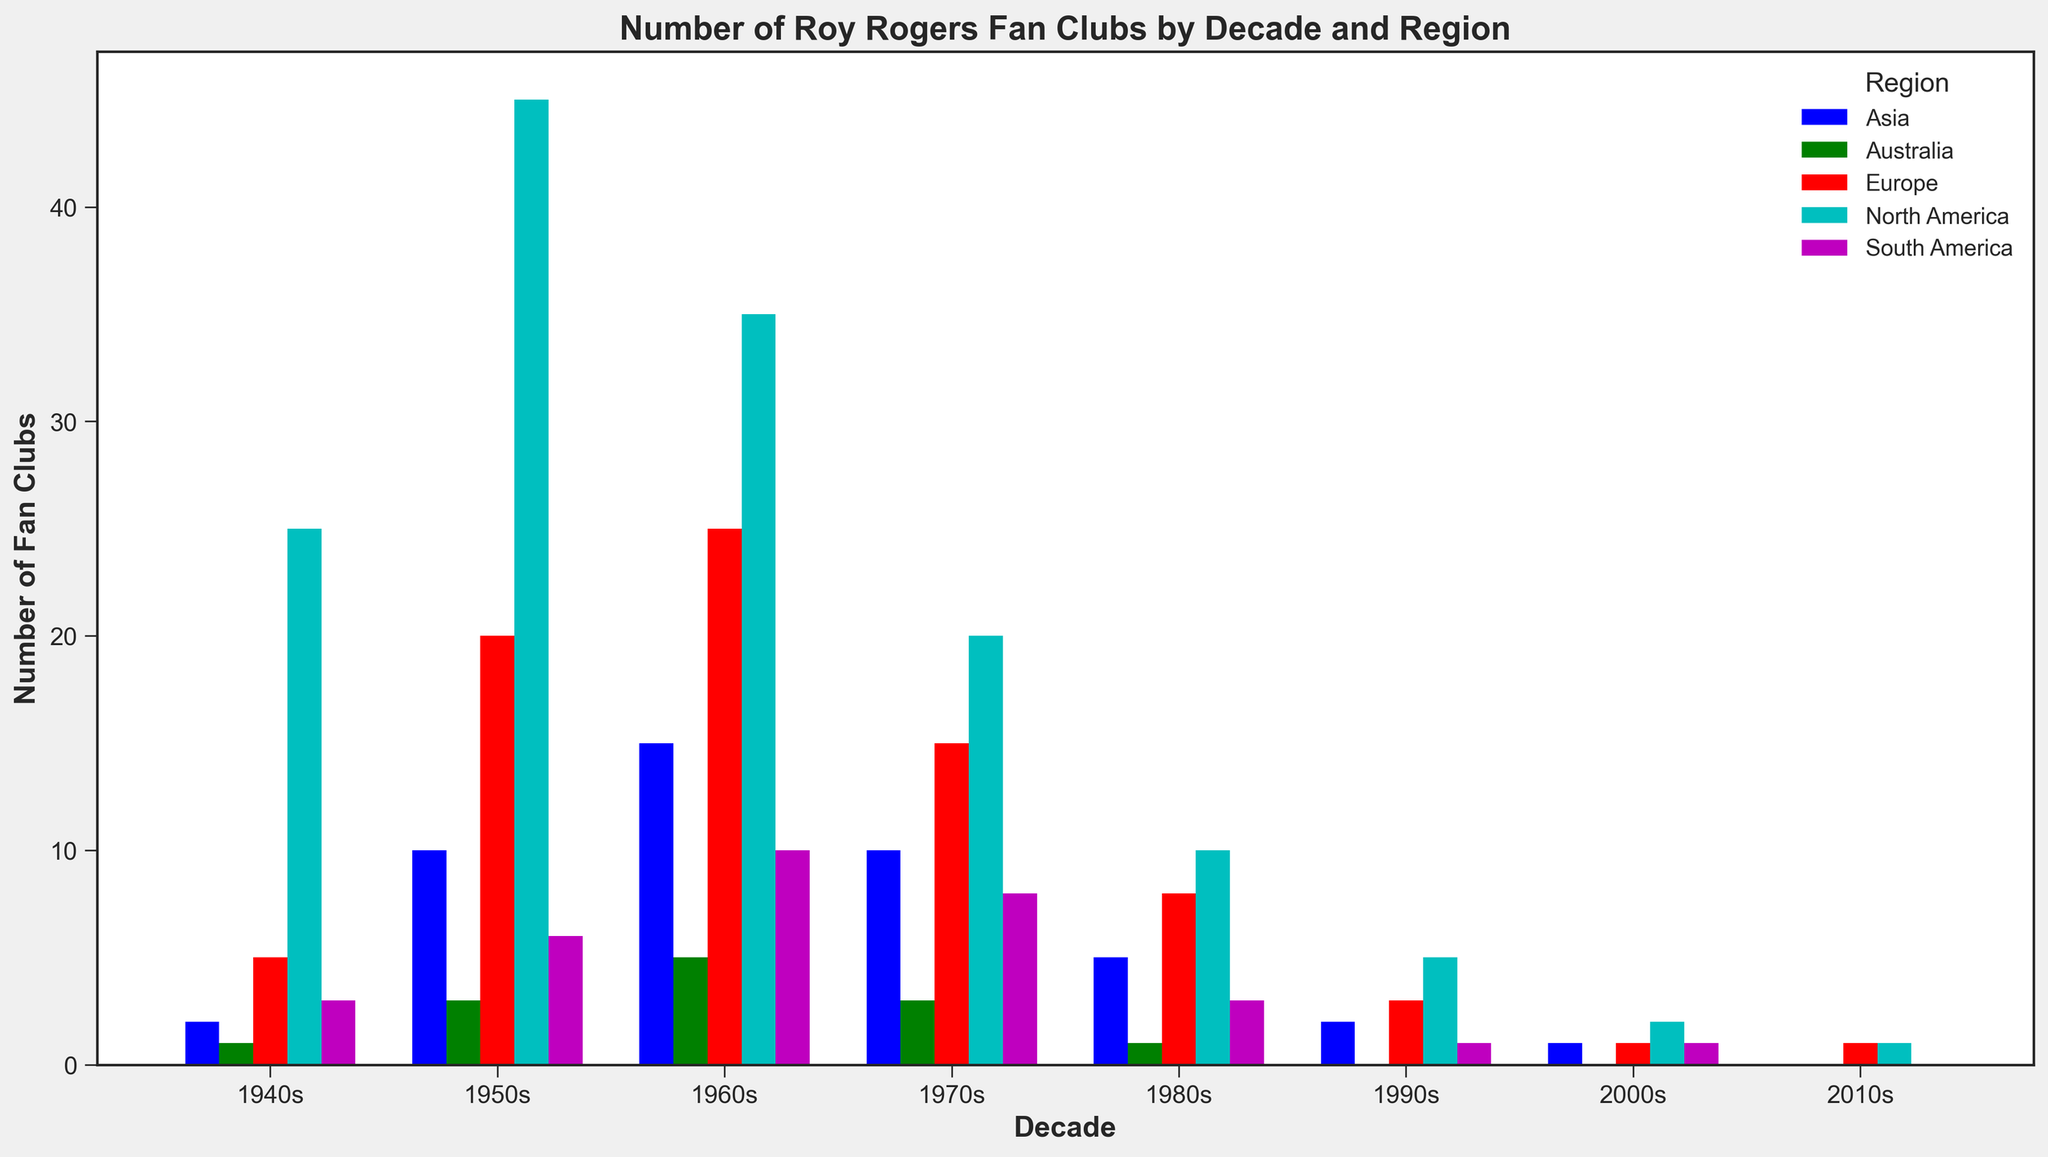Which region had the highest number of fan clubs in the 1950s? Look at the bars corresponding to the 1950s and identify the region with the tallest bar. North America's bar is the tallest in this decade.
Answer: North America How many more fan clubs were there in Europe in the 1960s compared to the 1950s? Compare the height of the bars for Europe in the 1950s and 1960s. The number for the 1960s (25) minus the number for the 1950s (20) gives us the difference.
Answer: 5 Which decade saw the highest overall number of fan clubs across all regions? Sum the heights of all bars for each decade and compare. The 1950s show the highest combined height.
Answer: 1950s How does the number of fan clubs in Asia change from the 1940s to the 2010s? Observe the height of the bars for Asia from the 1940s through to the 2010s. Asia starts with 2 in the 1940s, peaks at 15 in the 1960s, and drops to 0 in the 2010s.
Answer: Decreases What was the total number of fan clubs in the 1980s? Sum the heights of all the bars for the 1980s. (10 + 8 + 5 + 3 + 1)
Answer: 27 In which decade did South America see the largest number of fan clubs? Look at the bars representing South America and identify the decade with the tallest bar. The tallest bar is in the 1960s.
Answer: 1960s Compare the number of fan clubs in North America and Australia in the 1970s. Which had more? Compare the bars for North America and Australia in the 1970s. North America has a taller bar (20) compared to Australia (3).
Answer: North America What is the smallest number of fan clubs in any region in any decade? Identify the shortest bar across all decades and regions. The shortest bar is 0 in Australia in the 1990s and 2000s, and in Asia, South America, and Australia in the 2010s.
Answer: 0 By how much did the number of fan clubs in North America decrease from the 1960s to the 1980s? Compare the height of the bars for North America between the 1960s and 1980s. The number for the 1960s is 35, and the number for the 1980s is 10, so the drop is 25.
Answer: 25 What's the average number of fan clubs in Europe across all decades? Sum the number of fan clubs in Europe for each decade and divide by the number of decades. (5 + 20 + 25 + 15 + 8 + 3 + 1 + 1) / 8 = 9.75
Answer: 9.75 